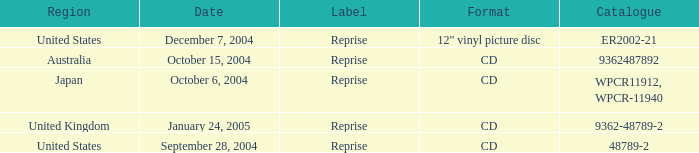What is the october 15, 2004 directory? 9362487892.0. 